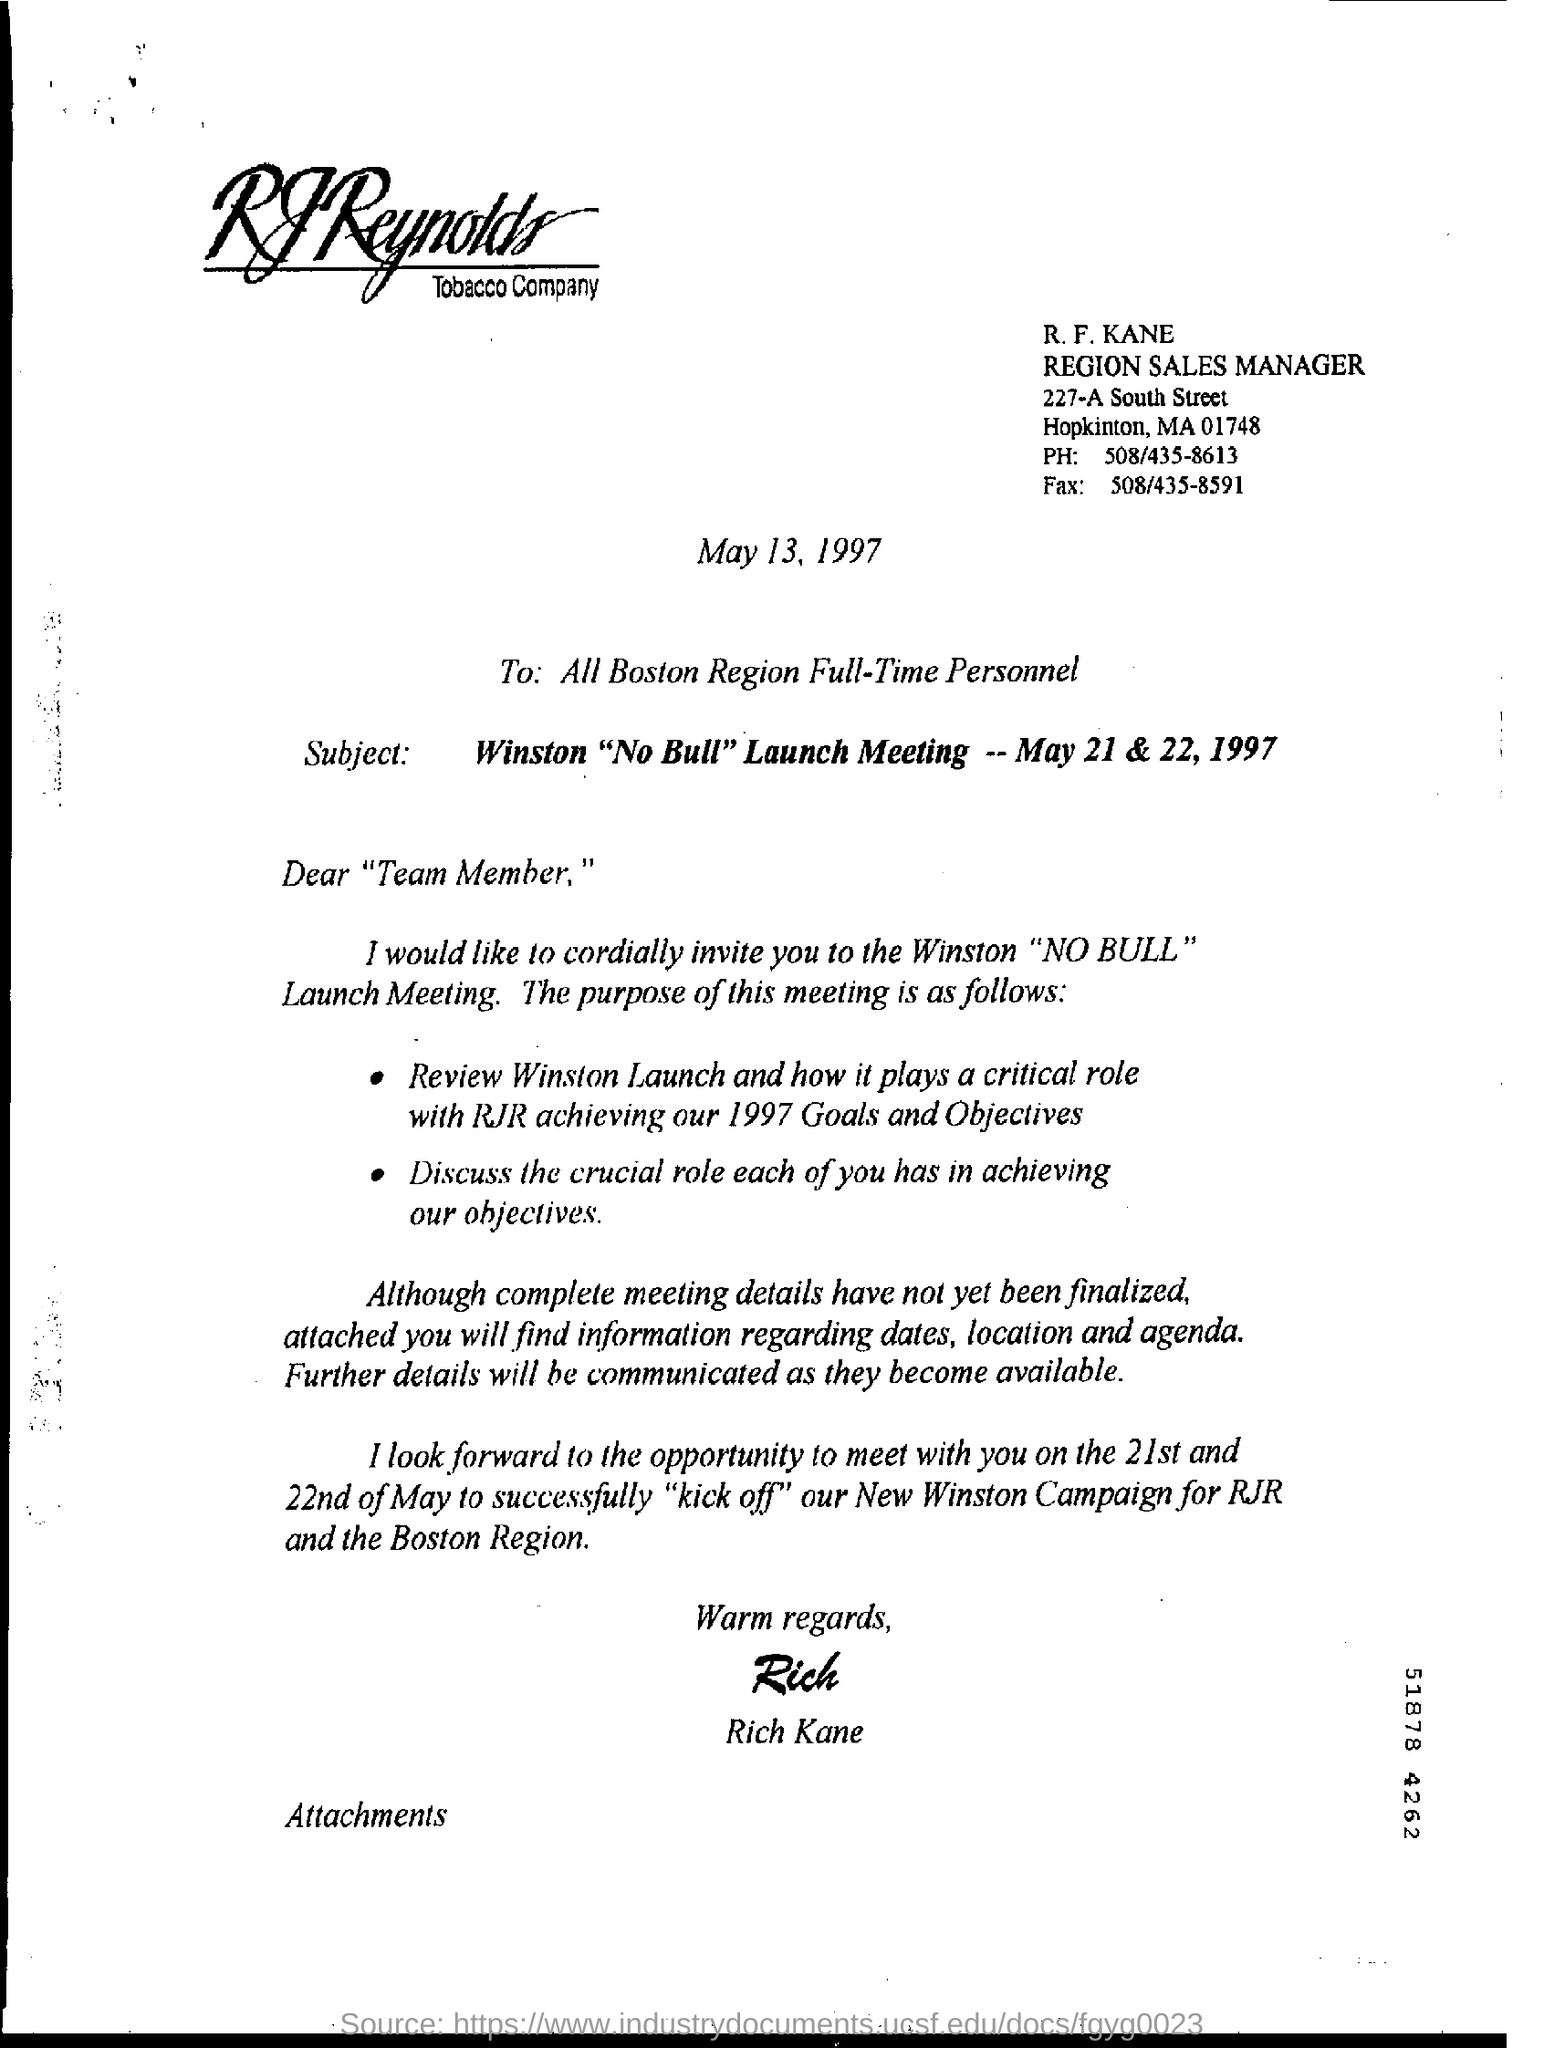Draw attention to some important aspects in this diagram. The fax number mentioned is 508/435-8591. The phone number mentioned is 508/435-8613. 